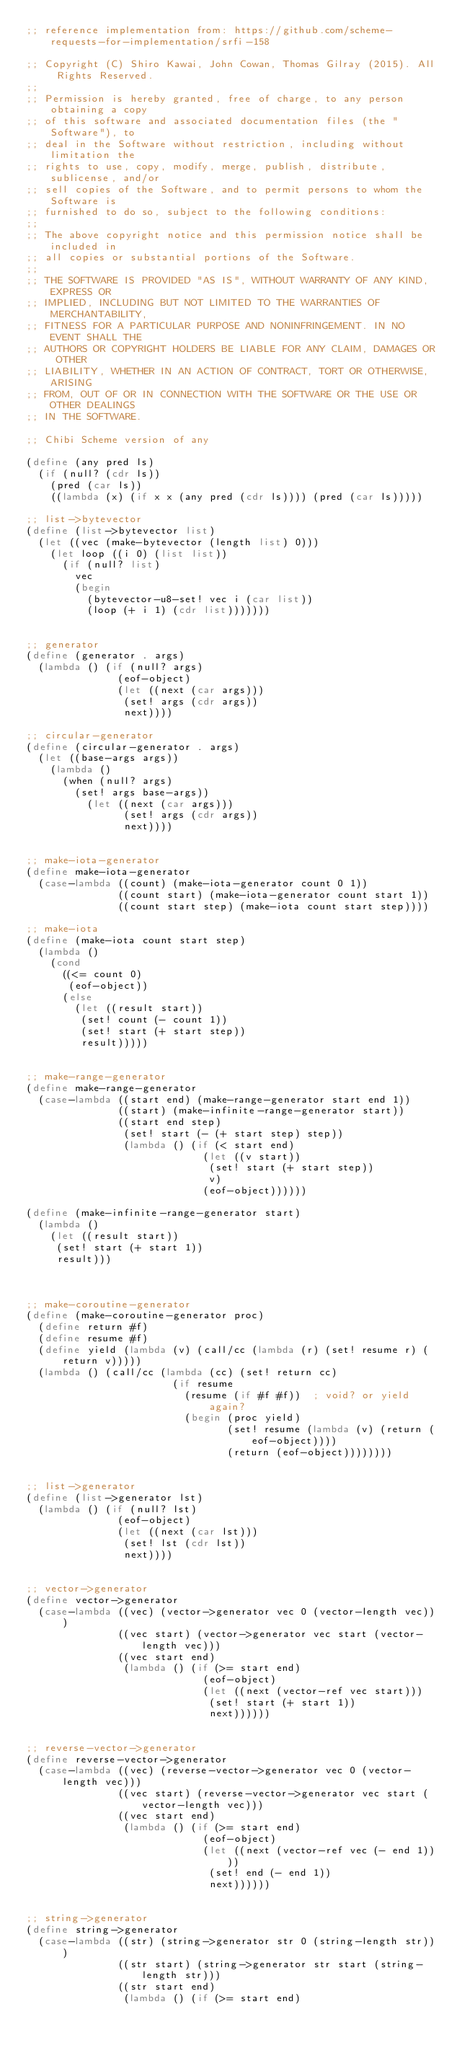Convert code to text. <code><loc_0><loc_0><loc_500><loc_500><_Scheme_>;; reference implementation from: https://github.com/scheme-requests-for-implementation/srfi-158

;; Copyright (C) Shiro Kawai, John Cowan, Thomas Gilray (2015). All Rights Reserved.
;;
;; Permission is hereby granted, free of charge, to any person obtaining a copy
;; of this software and associated documentation files (the "Software"), to
;; deal in the Software without restriction, including without limitation the
;; rights to use, copy, modify, merge, publish, distribute, sublicense, and/or
;; sell copies of the Software, and to permit persons to whom the Software is
;; furnished to do so, subject to the following conditions:
;;
;; The above copyright notice and this permission notice shall be included in
;; all copies or substantial portions of the Software.
;;
;; THE SOFTWARE IS PROVIDED "AS IS", WITHOUT WARRANTY OF ANY KIND, EXPRESS OR
;; IMPLIED, INCLUDING BUT NOT LIMITED TO THE WARRANTIES OF MERCHANTABILITY,
;; FITNESS FOR A PARTICULAR PURPOSE AND NONINFRINGEMENT. IN NO EVENT SHALL THE
;; AUTHORS OR COPYRIGHT HOLDERS BE LIABLE FOR ANY CLAIM, DAMAGES OR OTHER
;; LIABILITY, WHETHER IN AN ACTION OF CONTRACT, TORT OR OTHERWISE, ARISING
;; FROM, OUT OF OR IN CONNECTION WITH THE SOFTWARE OR THE USE OR OTHER DEALINGS
;; IN THE SOFTWARE.

;; Chibi Scheme version of any

(define (any pred ls)
  (if (null? (cdr ls))
    (pred (car ls))
    ((lambda (x) (if x x (any pred (cdr ls)))) (pred (car ls)))))

;; list->bytevector
(define (list->bytevector list)
  (let ((vec (make-bytevector (length list) 0)))
    (let loop ((i 0) (list list))
      (if (null? list)
        vec
        (begin
          (bytevector-u8-set! vec i (car list))
          (loop (+ i 1) (cdr list)))))))


;; generator
(define (generator . args)
  (lambda () (if (null? args)
               (eof-object)
               (let ((next (car args)))
                (set! args (cdr args))
                next))))

;; circular-generator
(define (circular-generator . args)
  (let ((base-args args))
    (lambda ()
      (when (null? args)
        (set! args base-args))
          (let ((next (car args)))
                (set! args (cdr args))
                next))))


;; make-iota-generator
(define make-iota-generator
  (case-lambda ((count) (make-iota-generator count 0 1))
               ((count start) (make-iota-generator count start 1))
               ((count start step) (make-iota count start step))))

;; make-iota
(define (make-iota count start step)
  (lambda ()
    (cond
      ((<= count 0)
       (eof-object))
      (else
        (let ((result start))
         (set! count (- count 1))
         (set! start (+ start step))
         result)))))


;; make-range-generator
(define make-range-generator
  (case-lambda ((start end) (make-range-generator start end 1))
               ((start) (make-infinite-range-generator start))
               ((start end step)
                (set! start (- (+ start step) step))
                (lambda () (if (< start end)
                             (let ((v start))
                              (set! start (+ start step))
                              v)
                             (eof-object))))))

(define (make-infinite-range-generator start)
  (lambda ()
    (let ((result start))
     (set! start (+ start 1))
     result)))



;; make-coroutine-generator
(define (make-coroutine-generator proc)
  (define return #f)
  (define resume #f)
  (define yield (lambda (v) (call/cc (lambda (r) (set! resume r) (return v)))))
  (lambda () (call/cc (lambda (cc) (set! return cc)
                        (if resume
                          (resume (if #f #f))  ; void? or yield again?
                          (begin (proc yield)
                                 (set! resume (lambda (v) (return (eof-object))))
                                 (return (eof-object))))))))


;; list->generator
(define (list->generator lst)
  (lambda () (if (null? lst)
               (eof-object)
               (let ((next (car lst)))
                (set! lst (cdr lst))
                next))))


;; vector->generator
(define vector->generator
  (case-lambda ((vec) (vector->generator vec 0 (vector-length vec)))
               ((vec start) (vector->generator vec start (vector-length vec)))
               ((vec start end)
                (lambda () (if (>= start end)
                             (eof-object)
                             (let ((next (vector-ref vec start)))
                              (set! start (+ start 1))
                              next))))))


;; reverse-vector->generator
(define reverse-vector->generator
  (case-lambda ((vec) (reverse-vector->generator vec 0 (vector-length vec)))
               ((vec start) (reverse-vector->generator vec start (vector-length vec)))
               ((vec start end)
                (lambda () (if (>= start end)
                             (eof-object)
                             (let ((next (vector-ref vec (- end 1))))
                              (set! end (- end 1))
                              next))))))


;; string->generator
(define string->generator
  (case-lambda ((str) (string->generator str 0 (string-length str)))
               ((str start) (string->generator str start (string-length str)))
               ((str start end)
                (lambda () (if (>= start end)</code> 